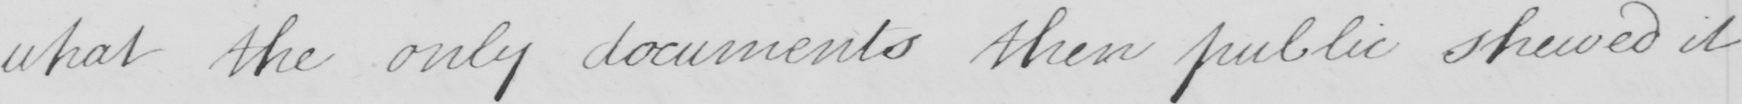What text is written in this handwritten line? what the only documents then public shewed it 